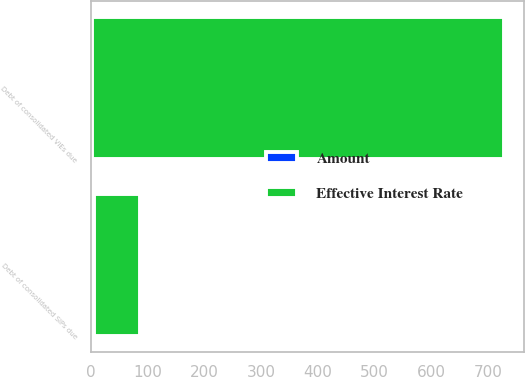Convert chart to OTSL. <chart><loc_0><loc_0><loc_500><loc_500><stacked_bar_chart><ecel><fcel>Debt of consolidated SIPs due<fcel>Debt of consolidated VIEs due<nl><fcel>Effective Interest Rate<fcel>81.2<fcel>726.1<nl><fcel>Amount<fcel>4.71<fcel>1.62<nl></chart> 